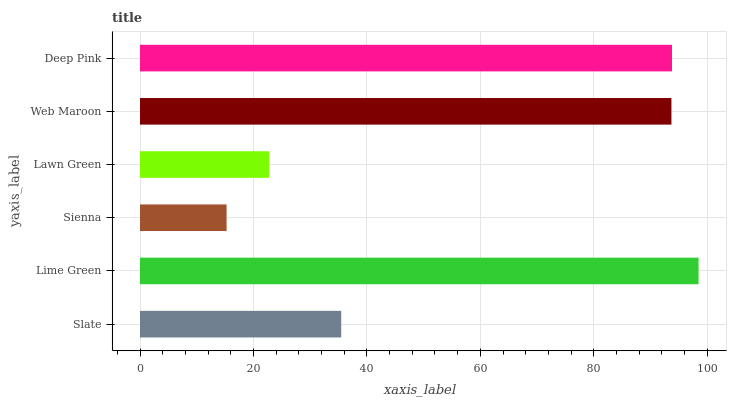Is Sienna the minimum?
Answer yes or no. Yes. Is Lime Green the maximum?
Answer yes or no. Yes. Is Lime Green the minimum?
Answer yes or no. No. Is Sienna the maximum?
Answer yes or no. No. Is Lime Green greater than Sienna?
Answer yes or no. Yes. Is Sienna less than Lime Green?
Answer yes or no. Yes. Is Sienna greater than Lime Green?
Answer yes or no. No. Is Lime Green less than Sienna?
Answer yes or no. No. Is Web Maroon the high median?
Answer yes or no. Yes. Is Slate the low median?
Answer yes or no. Yes. Is Lawn Green the high median?
Answer yes or no. No. Is Deep Pink the low median?
Answer yes or no. No. 